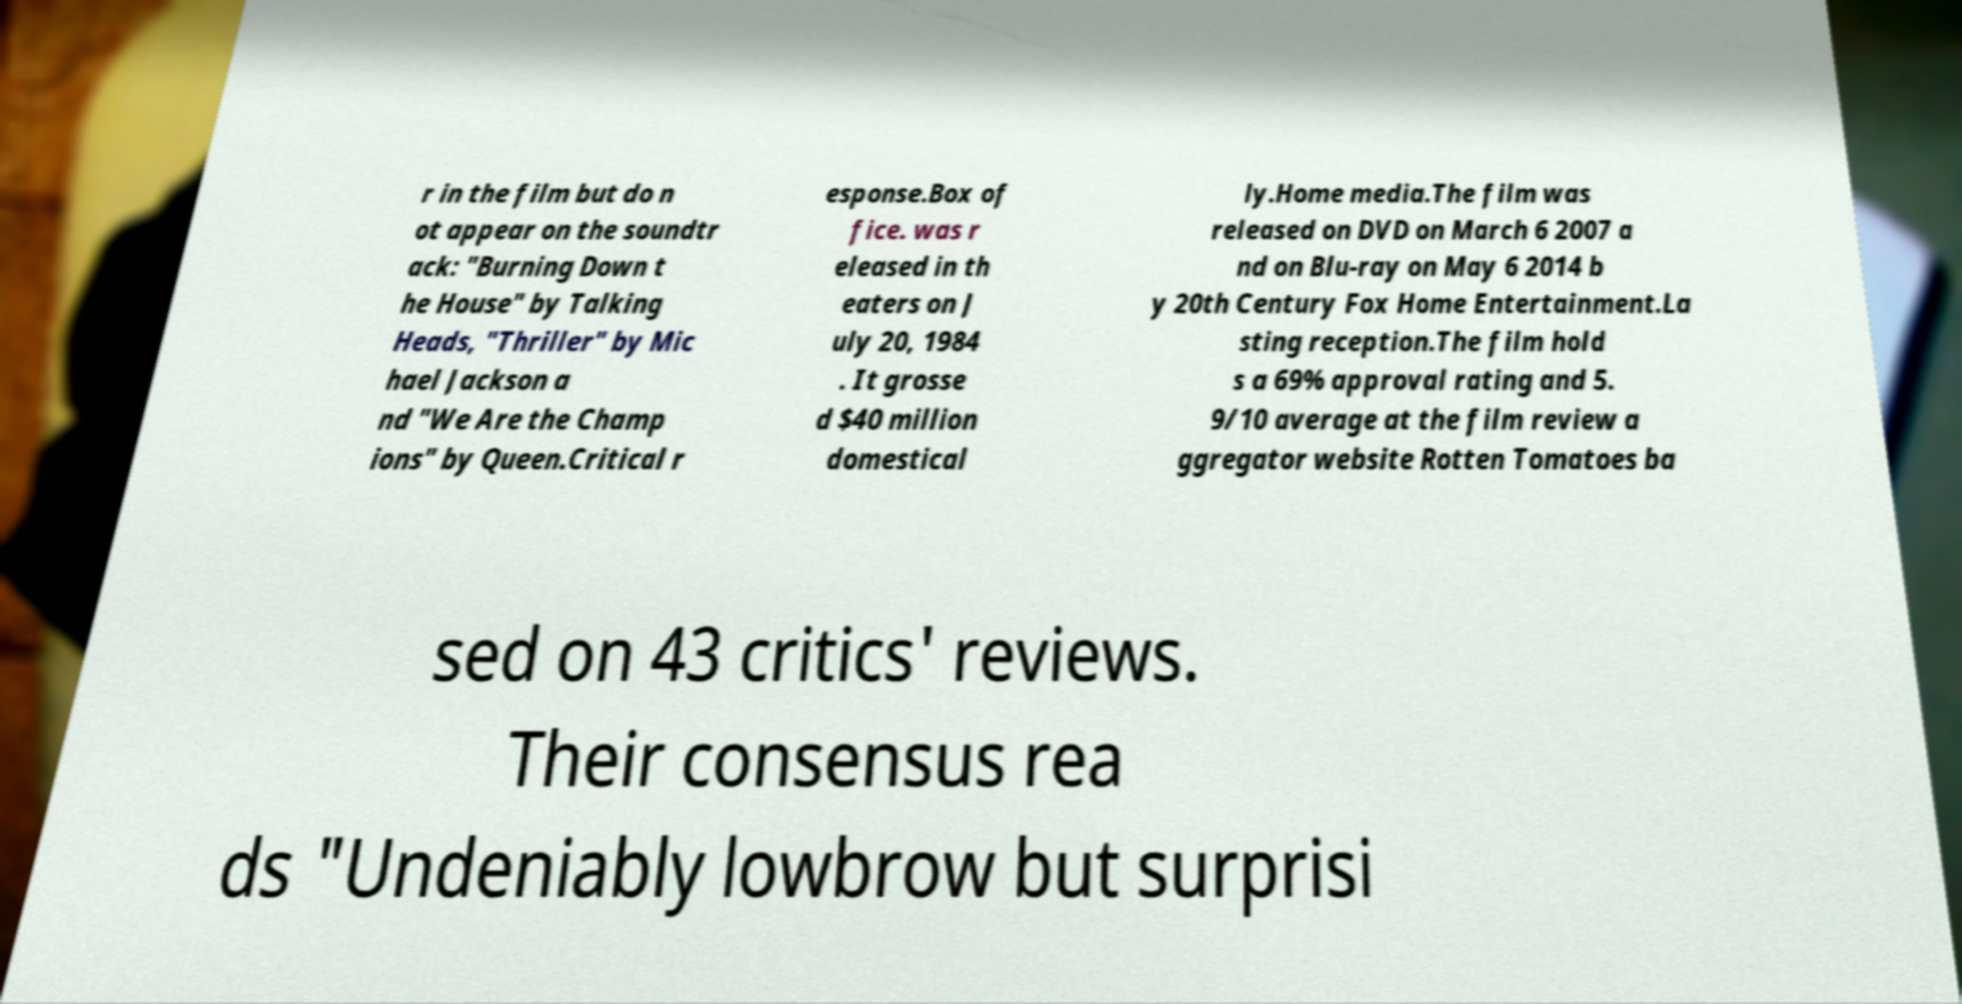Please identify and transcribe the text found in this image. r in the film but do n ot appear on the soundtr ack: "Burning Down t he House" by Talking Heads, "Thriller" by Mic hael Jackson a nd "We Are the Champ ions" by Queen.Critical r esponse.Box of fice. was r eleased in th eaters on J uly 20, 1984 . It grosse d $40 million domestical ly.Home media.The film was released on DVD on March 6 2007 a nd on Blu-ray on May 6 2014 b y 20th Century Fox Home Entertainment.La sting reception.The film hold s a 69% approval rating and 5. 9/10 average at the film review a ggregator website Rotten Tomatoes ba sed on 43 critics' reviews. Their consensus rea ds "Undeniably lowbrow but surprisi 